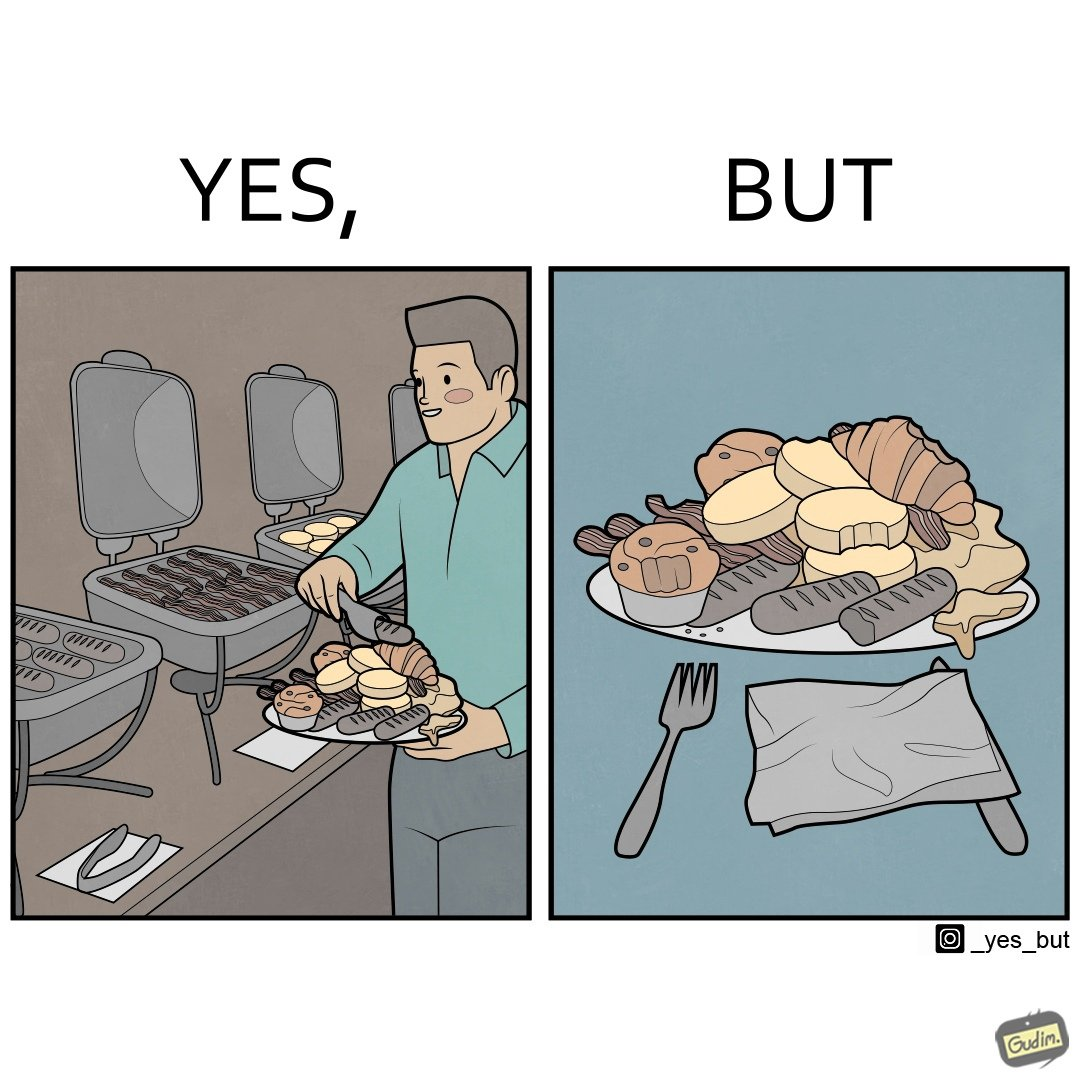Is this a satirical image? Yes, this image is satirical. 